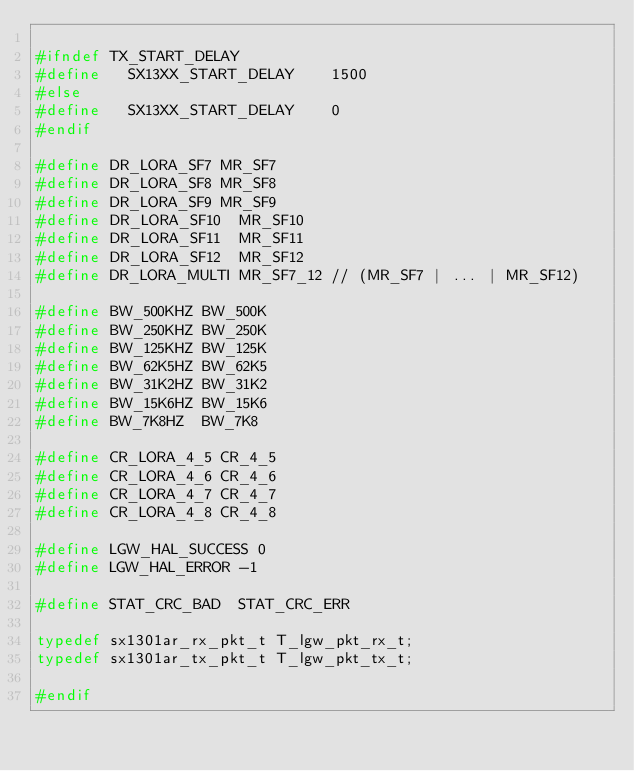Convert code to text. <code><loc_0><loc_0><loc_500><loc_500><_C_>
#ifndef	TX_START_DELAY
#define		SX13XX_START_DELAY		1500
#else
#define		SX13XX_START_DELAY		0
#endif

#define	DR_LORA_SF7	MR_SF7
#define	DR_LORA_SF8	MR_SF8
#define	DR_LORA_SF9	MR_SF9
#define	DR_LORA_SF10	MR_SF10
#define	DR_LORA_SF11	MR_SF11
#define	DR_LORA_SF12	MR_SF12
#define	DR_LORA_MULTI	MR_SF7_12	// (MR_SF7 | ... | MR_SF12)

#define	BW_500KHZ	BW_500K
#define	BW_250KHZ	BW_250K
#define	BW_125KHZ	BW_125K
#define	BW_62K5HZ	BW_62K5
#define	BW_31K2HZ	BW_31K2
#define	BW_15K6HZ	BW_15K6
#define	BW_7K8HZ	BW_7K8

#define	CR_LORA_4_5	CR_4_5
#define	CR_LORA_4_6	CR_4_6
#define	CR_LORA_4_7	CR_4_7
#define	CR_LORA_4_8	CR_4_8

#define	LGW_HAL_SUCCESS	0
#define	LGW_HAL_ERROR	-1

#define	STAT_CRC_BAD	STAT_CRC_ERR

typedef	sx1301ar_rx_pkt_t	T_lgw_pkt_rx_t;
typedef	sx1301ar_tx_pkt_t	T_lgw_pkt_tx_t;

#endif

</code> 